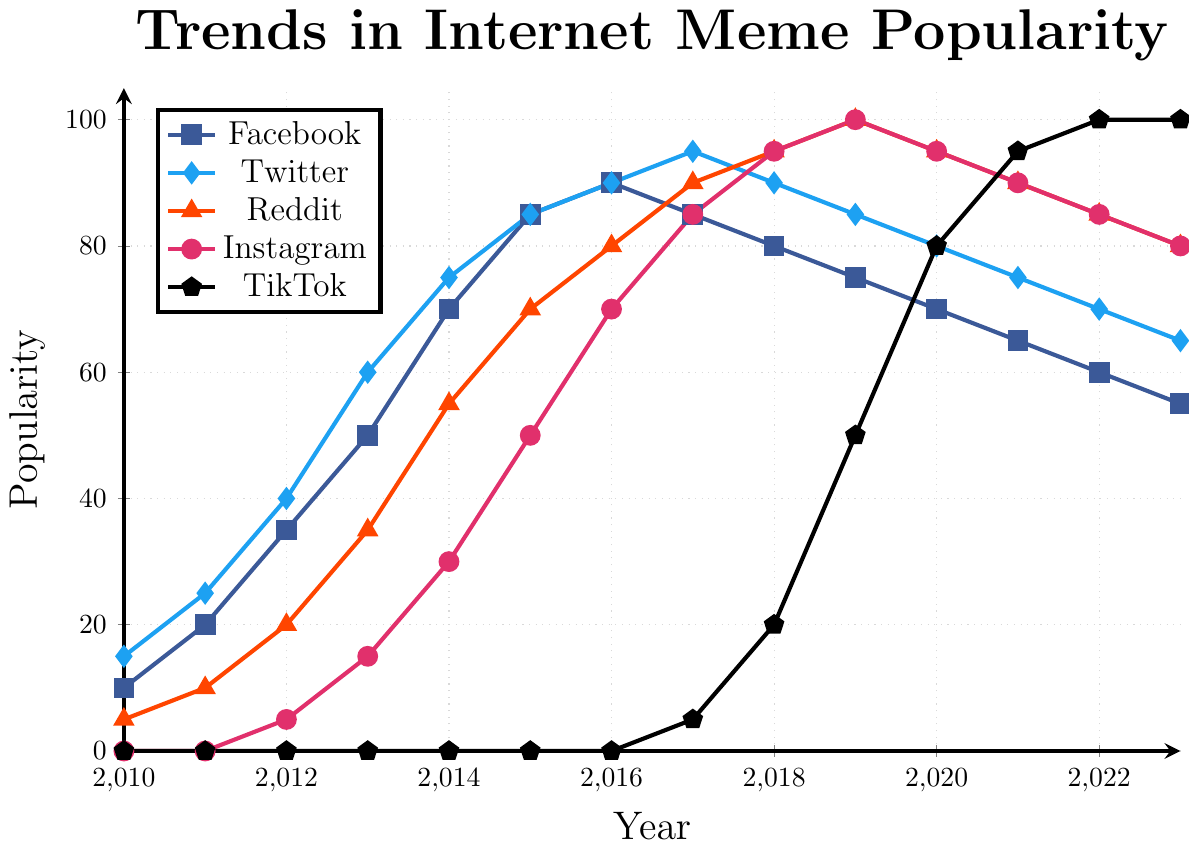What platform had the highest meme popularity in 2023? To find the platform with the highest meme popularity, look at the endpoint of each line on the chart in 2023. TikTok reaches the highest value of 100.
Answer: TikTok What is the difference in meme popularity between Twitter and Facebook in 2015? Locate the popularity values for both Twitter and Facebook in 2015. Twitter has a popularity of 85, and Facebook also has 85. The difference is 85 - 85 = 0.
Answer: 0 Which platform had the most significant increase in popularity from 2016 to 2017? Determine the change in popularity for each platform between 2016 and 2017. Calculate the difference for each: 
- Facebook: 85 - 90 = -5
- Twitter: 95 - 90 = 5
- Reddit: 90 - 80 = 10
- Instagram: 85 - 70 = 15
- TikTok: 5 - 0 = 5
The most significant increase is by Instagram, from 70 to 85, an increase of 15.
Answer: Instagram By how much did Reddit's meme popularity change from 2018 to 2019? Check the values for Reddit in 2018 and 2019. In 2018, Reddit is at 95, and in 2019, it's at 100. The change is 100 - 95 = 5.
Answer: 5 Which two platforms had equal meme popularity in 2019? In 2019, look for equal values on the y-axis for any platforms. Both Reddit and Instagram have a popularity of 100.
Answer: Reddit and Instagram What is the average meme popularity of TikTok from 2019 to 2023? Examine the values for TikTok from 2019 to 2023:
- 2019: 50
- 2020: 80
- 2021: 95
- 2022: 100
- 2023: 100
Sum these values: 50 + 80 + 95 + 100 + 100 = 425. The average is 425 / 5 = 85.
Answer: 85 Which platform had the steepest decline in popularity after 2016 and by how much? Identify the platform with the largest drop from 2016 onwards:
- Facebook: 90 -> 85 -> 80 -> 75 -> 70 -> 65 -> 60 -> 55 (decline of 35)
- Twitter: 90 -> 95 -> 90 -> 85 -> 80 -> 75 -> 70 -> 65 (decline of 25)
- Reddit: 80 -> 90 (increase thereafter)
- Instagram: 70 -> 85 (increase thereafter)
- TikTok: 0 -> 5 (increase thereafter)
The steepest decline is for Facebook, from 90 to 55, a decrease of 35.
Answer: Facebook by 35 What year did Instagram surpass Reddit in meme popularity for the first time? Compare Instagram and Reddit values year by year. Instagram surpasses Reddit in 2018 with values Instagram (95) and Reddit (95). Though they are equal in 2018, in 2019, Instagram reached 100, which is the same as Reddit. If re-check in 2017 the values, Instagram (85) and Reddit (90), Instagram surpassed by 2018.
Answer: 2018 